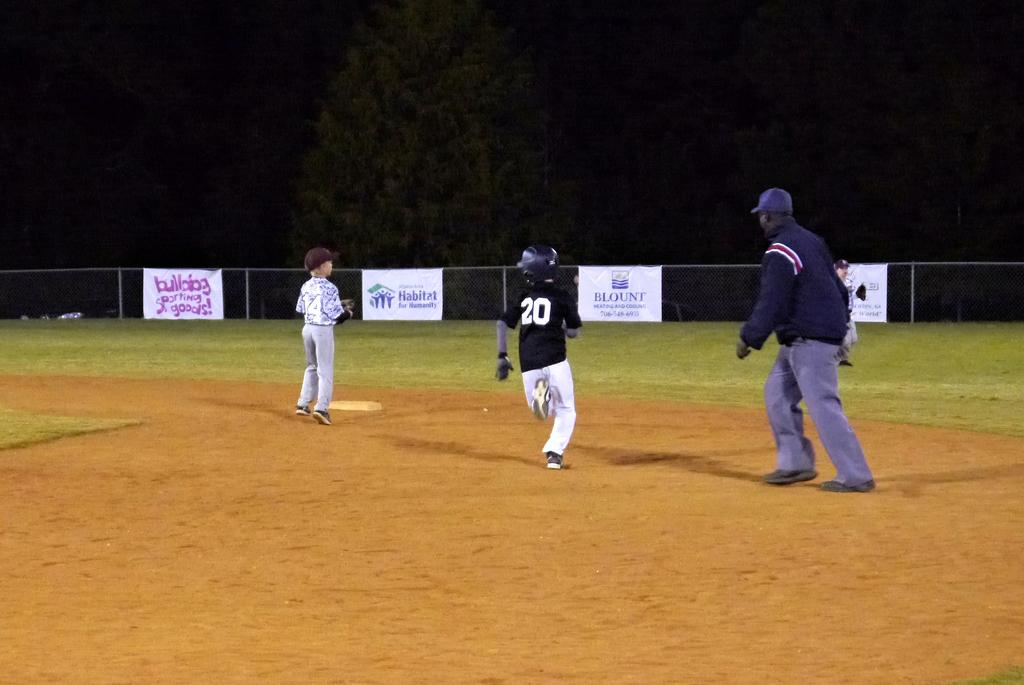<image>
Share a concise interpretation of the image provided. Number 20 heads into second base with a Blount advertisement in the background. 